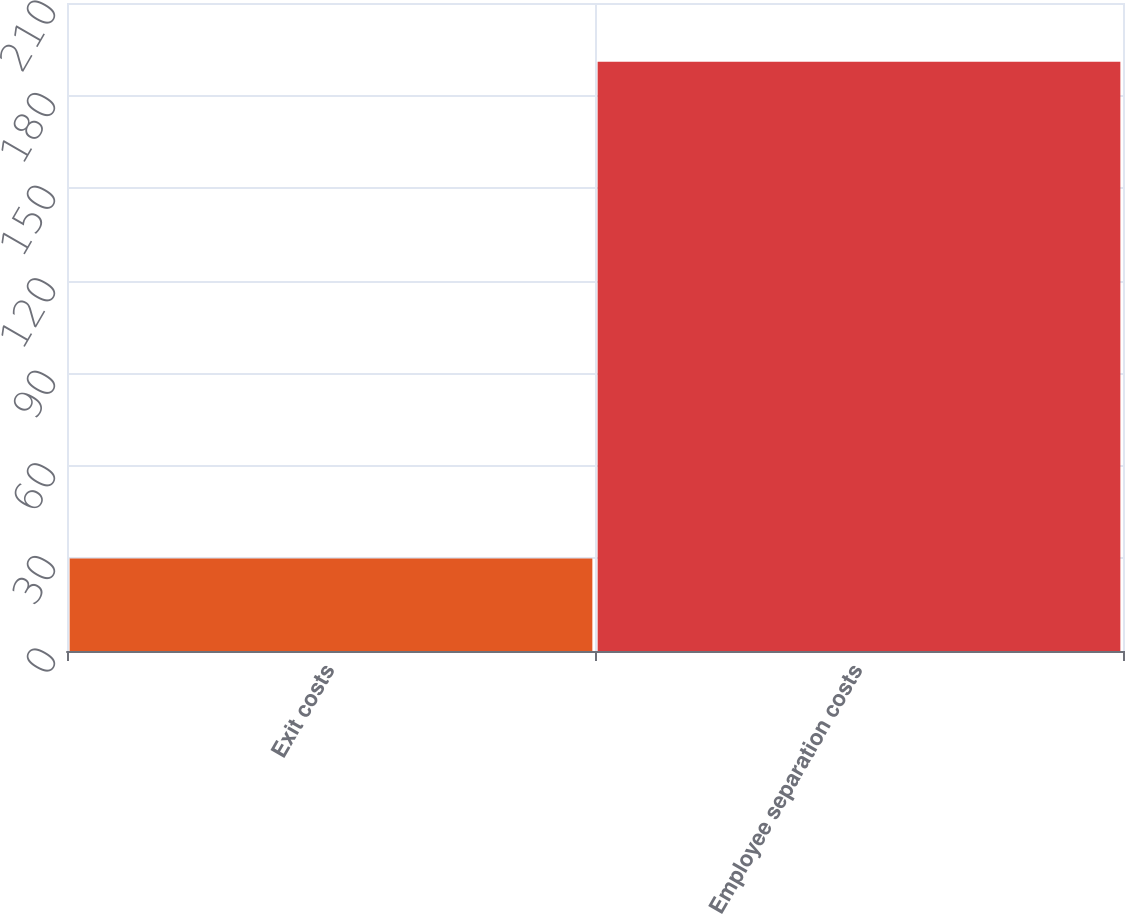Convert chart to OTSL. <chart><loc_0><loc_0><loc_500><loc_500><bar_chart><fcel>Exit costs<fcel>Employee separation costs<nl><fcel>30<fcel>191<nl></chart> 